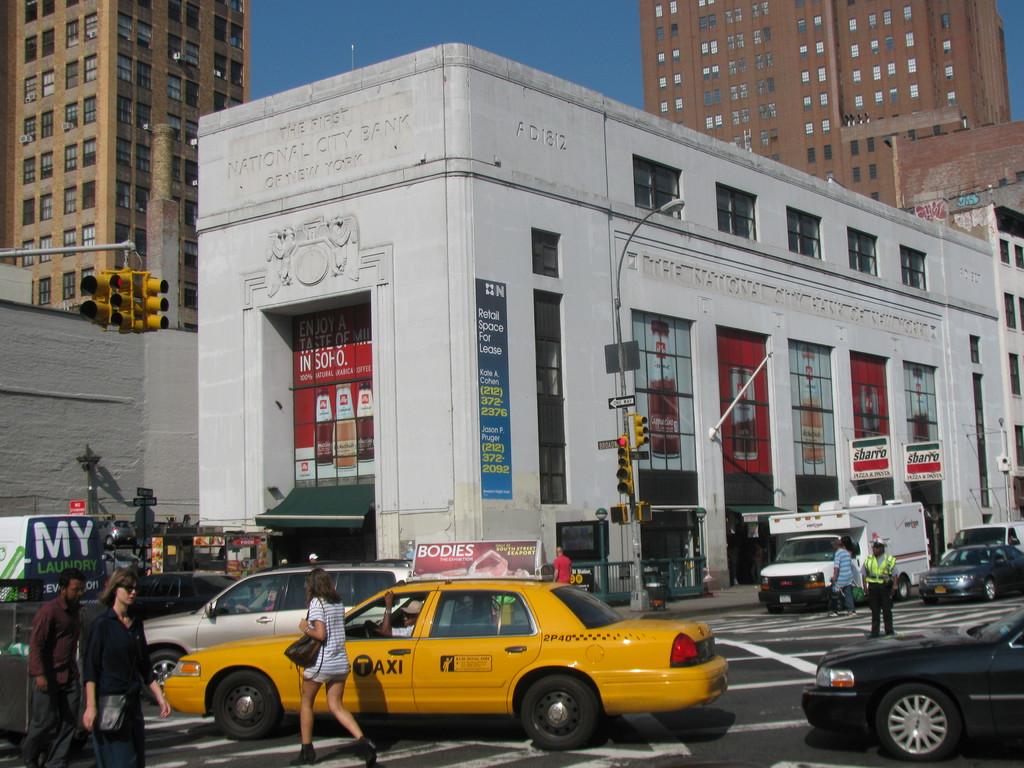What is advertised on the top of the cab in all caps?
Keep it short and to the point. Bodies. Who's laundry is mentioned on the sign to the left?
Provide a succinct answer. My. 